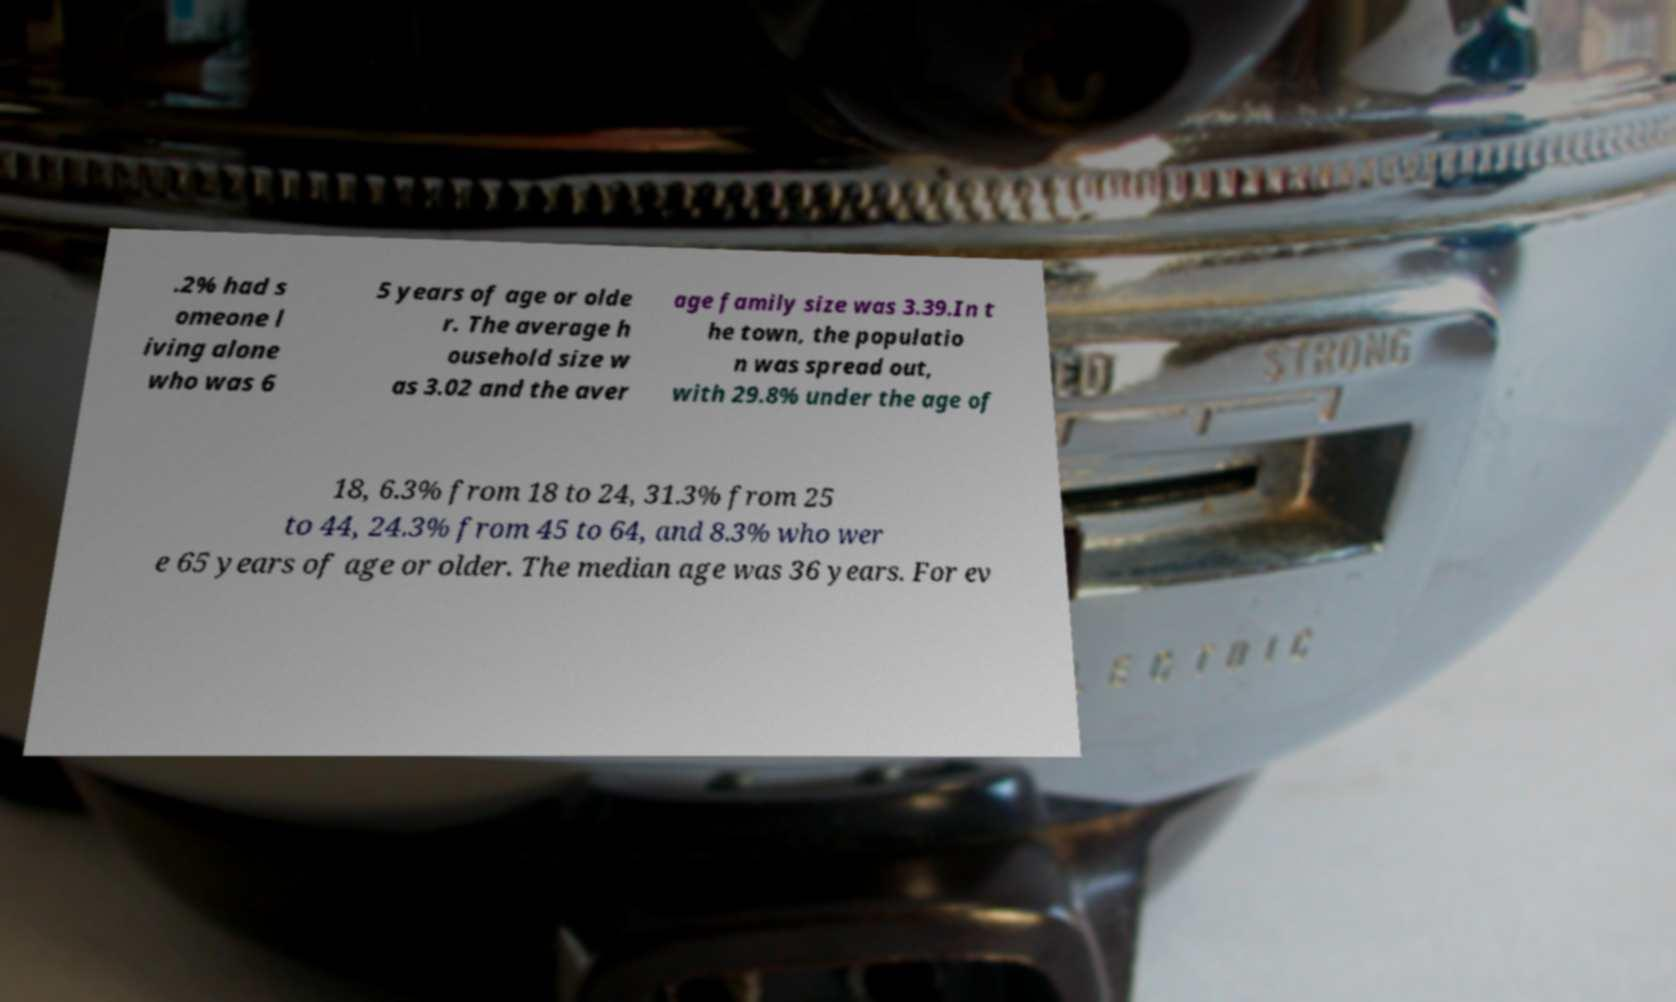There's text embedded in this image that I need extracted. Can you transcribe it verbatim? .2% had s omeone l iving alone who was 6 5 years of age or olde r. The average h ousehold size w as 3.02 and the aver age family size was 3.39.In t he town, the populatio n was spread out, with 29.8% under the age of 18, 6.3% from 18 to 24, 31.3% from 25 to 44, 24.3% from 45 to 64, and 8.3% who wer e 65 years of age or older. The median age was 36 years. For ev 